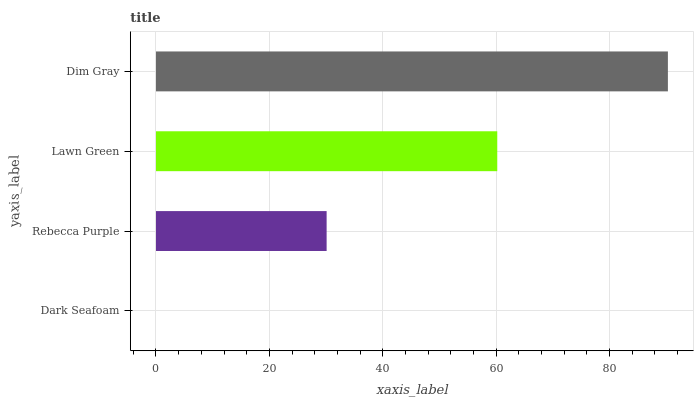Is Dark Seafoam the minimum?
Answer yes or no. Yes. Is Dim Gray the maximum?
Answer yes or no. Yes. Is Rebecca Purple the minimum?
Answer yes or no. No. Is Rebecca Purple the maximum?
Answer yes or no. No. Is Rebecca Purple greater than Dark Seafoam?
Answer yes or no. Yes. Is Dark Seafoam less than Rebecca Purple?
Answer yes or no. Yes. Is Dark Seafoam greater than Rebecca Purple?
Answer yes or no. No. Is Rebecca Purple less than Dark Seafoam?
Answer yes or no. No. Is Lawn Green the high median?
Answer yes or no. Yes. Is Rebecca Purple the low median?
Answer yes or no. Yes. Is Dim Gray the high median?
Answer yes or no. No. Is Dim Gray the low median?
Answer yes or no. No. 